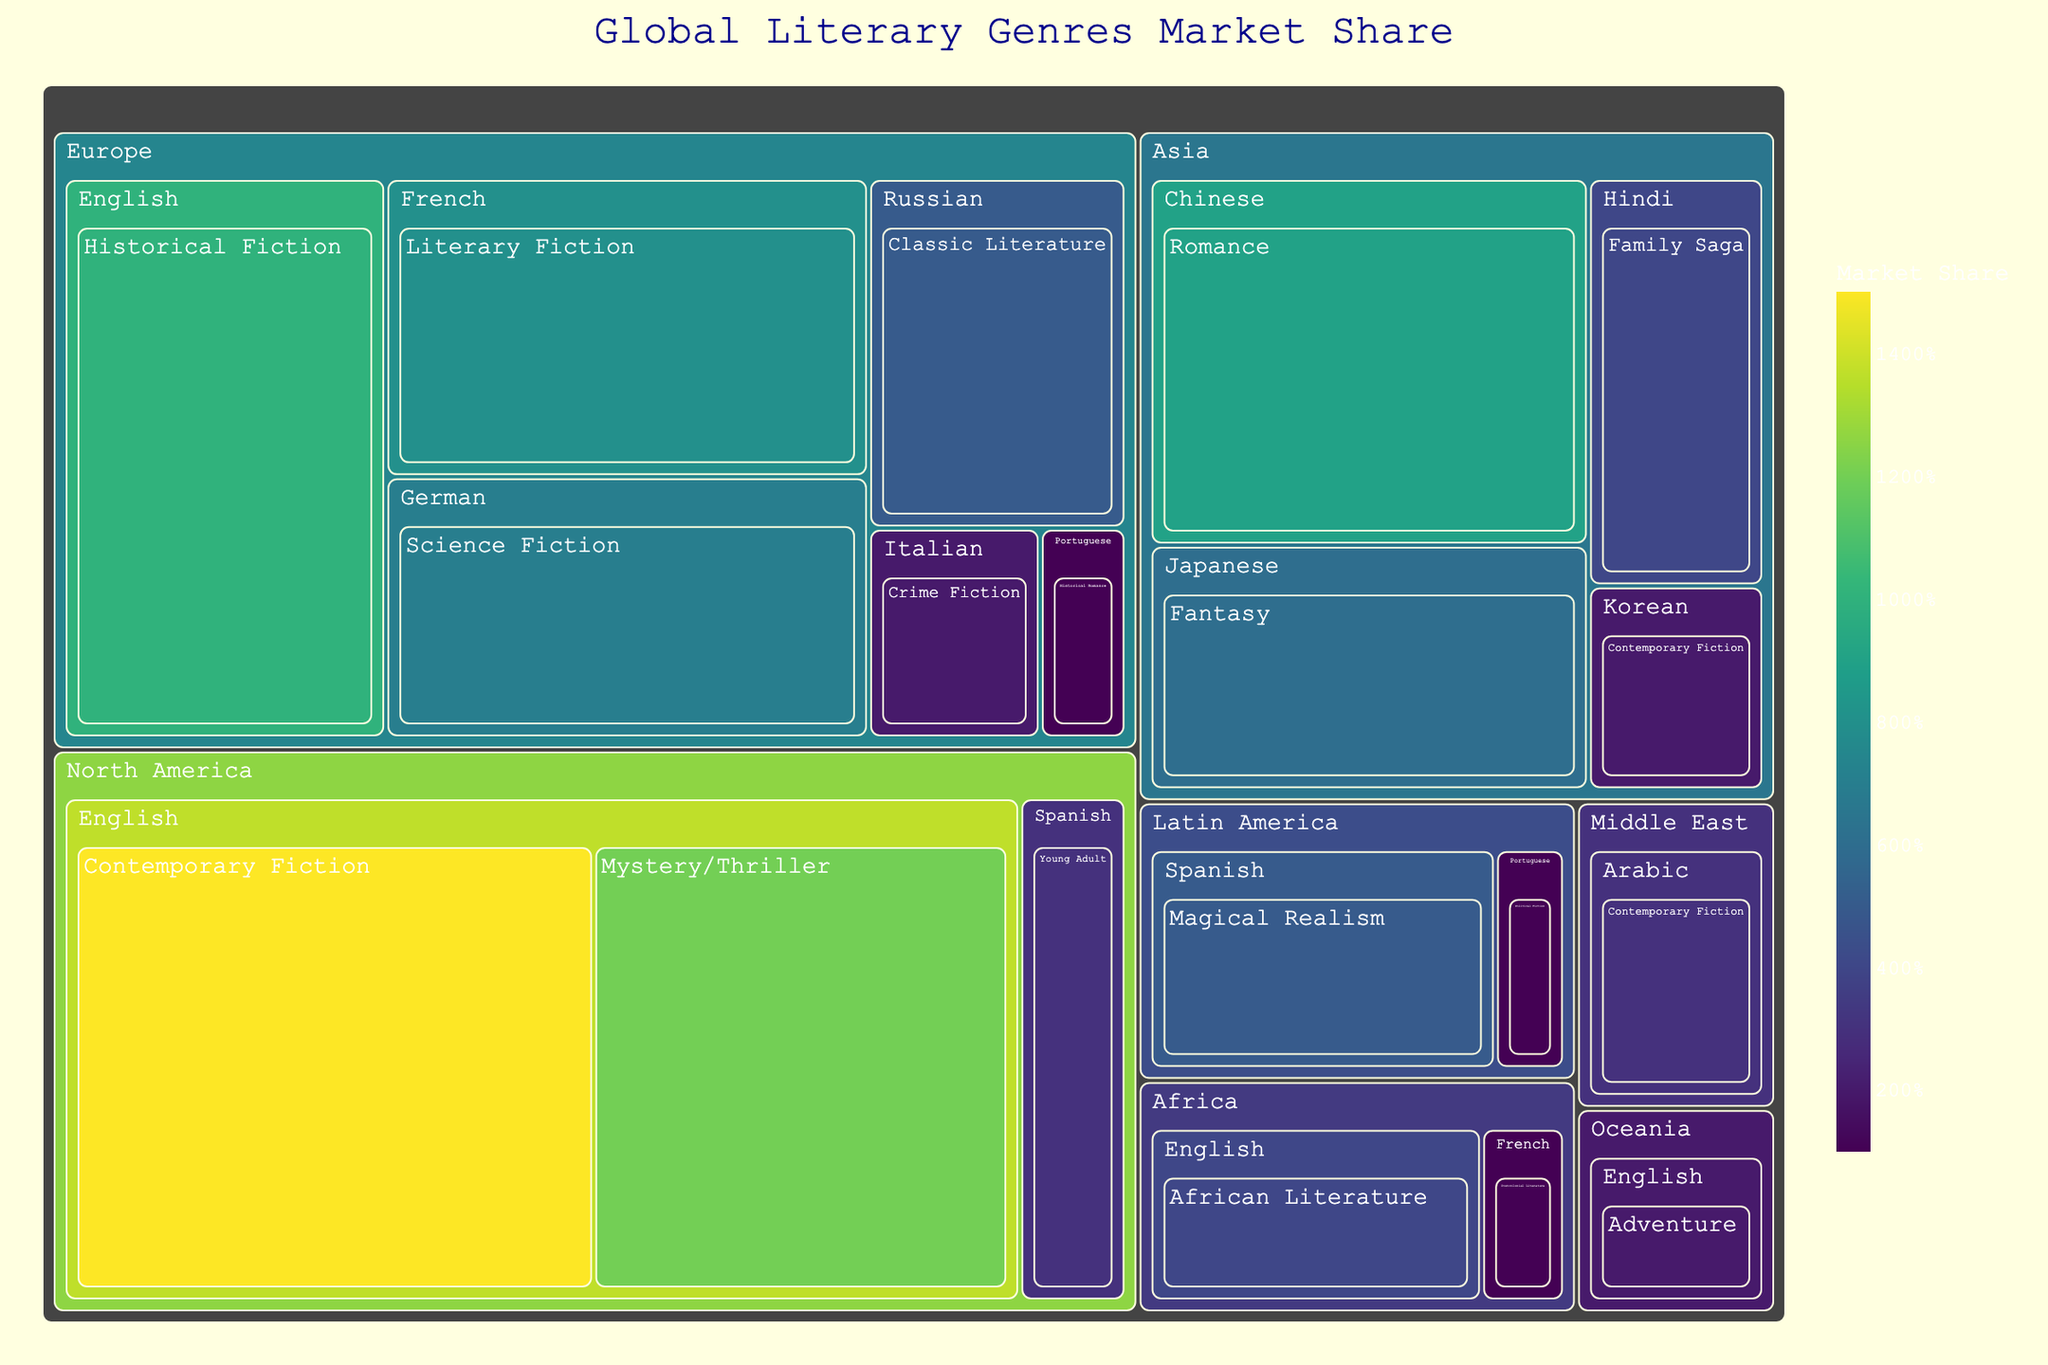What is the title of the figure? The title of the figure is typically displayed prominently at the top. In this case, it is "Global Literary Genres Market Share."
Answer: Global Literary Genres Market Share Which language under the 'Asia' region has the highest market share? By inspecting the plots under the 'Asia' region, the language with the highest market share is 'Chinese' with Romance, having a market share of 9%.
Answer: Chinese What is the combined market share of Literary Fiction genres across different regions? Identifying 'Literary Fiction' genres across different regions (Europe, where French has a share of 8%) and summing the individual market shares yields 8%.
Answer: 8% Which region has the smallest total market share, and what is its share? By comparing the total market shares of all regions, 'Oceania' has the smallest total market share, with a share of 2% (Adventure in English).
Answer: Oceania, 2% What is the difference in market share between 'Magical Realism' in Latin America (Spanish) and 'Contemporary Fiction' in North America (English)? 'Magical Realism' has a market share of 5%, and 'Contemporary Fiction' in North America has 15%. The difference is 15% - 5% = 10%.
Answer: 10% Which genre has the highest market share in 'Europe' and what is its value? Under the 'Europe' region, the genre with the highest market share is 'Historical Fiction' in English, with a share of 10%.
Answer: Historical Fiction, 10% List all languages appearing in the 'North America' region. By checking all the entries under 'North America', the languages are 'English' and 'Spanish'.
Answer: English, Spanish What is the average market share of genres under the 'Europe' region? Summing all market shares in 'Europe' (10+8+7+5+2+1) and dividing by the number of genres (6): (10+8+7+5+2+1)/6 = 33/6 ≈ 5.5%.
Answer: 5.5% How many genres are listed under the 'Asia' region? Counting genres under 'Asia', there are 'Romance', 'Fantasy', 'Contemporary Fiction', and 'Family Saga', resulting in four genres.
Answer: 4 Which genre in 'Africa' has the lowest market share and what is its value? Examining the genres in 'Africa', 'Postcolonial Literature' in French has the lowest market share with 1%.
Answer: Postcolonial Literature, 1% 